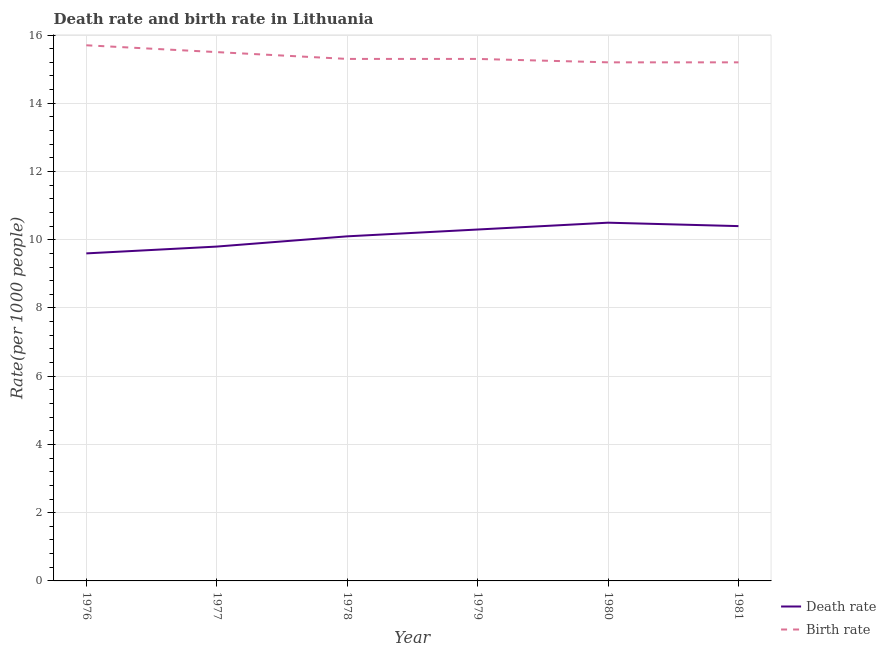How many different coloured lines are there?
Ensure brevity in your answer.  2. What is the birth rate in 1977?
Your response must be concise. 15.5. Across all years, what is the minimum death rate?
Provide a short and direct response. 9.6. In which year was the birth rate minimum?
Offer a very short reply. 1980. What is the total death rate in the graph?
Give a very brief answer. 60.7. What is the average death rate per year?
Ensure brevity in your answer.  10.12. In the year 1978, what is the difference between the death rate and birth rate?
Your response must be concise. -5.2. In how many years, is the birth rate greater than 11.6?
Provide a succinct answer. 6. What is the ratio of the birth rate in 1978 to that in 1981?
Your response must be concise. 1.01. Is the death rate in 1976 less than that in 1980?
Make the answer very short. Yes. Is the difference between the birth rate in 1976 and 1980 greater than the difference between the death rate in 1976 and 1980?
Offer a terse response. Yes. What is the difference between the highest and the second highest death rate?
Your response must be concise. 0.1. Does the death rate monotonically increase over the years?
Your answer should be very brief. No. Is the death rate strictly greater than the birth rate over the years?
Keep it short and to the point. No. Is the birth rate strictly less than the death rate over the years?
Provide a short and direct response. No. How many lines are there?
Offer a terse response. 2. What is the difference between two consecutive major ticks on the Y-axis?
Your answer should be very brief. 2. Are the values on the major ticks of Y-axis written in scientific E-notation?
Offer a very short reply. No. What is the title of the graph?
Your response must be concise. Death rate and birth rate in Lithuania. Does "Number of departures" appear as one of the legend labels in the graph?
Provide a succinct answer. No. What is the label or title of the X-axis?
Provide a short and direct response. Year. What is the label or title of the Y-axis?
Your answer should be very brief. Rate(per 1000 people). What is the Rate(per 1000 people) in Birth rate in 1976?
Your response must be concise. 15.7. What is the Rate(per 1000 people) in Birth rate in 1977?
Provide a succinct answer. 15.5. What is the Rate(per 1000 people) of Birth rate in 1978?
Make the answer very short. 15.3. What is the Rate(per 1000 people) of Birth rate in 1980?
Your response must be concise. 15.2. What is the Rate(per 1000 people) in Death rate in 1981?
Your response must be concise. 10.4. What is the Rate(per 1000 people) in Birth rate in 1981?
Your response must be concise. 15.2. Across all years, what is the maximum Rate(per 1000 people) of Death rate?
Give a very brief answer. 10.5. Across all years, what is the maximum Rate(per 1000 people) of Birth rate?
Your answer should be very brief. 15.7. What is the total Rate(per 1000 people) in Death rate in the graph?
Ensure brevity in your answer.  60.7. What is the total Rate(per 1000 people) of Birth rate in the graph?
Provide a succinct answer. 92.2. What is the difference between the Rate(per 1000 people) in Death rate in 1976 and that in 1977?
Provide a short and direct response. -0.2. What is the difference between the Rate(per 1000 people) of Birth rate in 1976 and that in 1977?
Provide a succinct answer. 0.2. What is the difference between the Rate(per 1000 people) of Death rate in 1976 and that in 1979?
Provide a succinct answer. -0.7. What is the difference between the Rate(per 1000 people) of Birth rate in 1976 and that in 1981?
Your answer should be very brief. 0.5. What is the difference between the Rate(per 1000 people) in Birth rate in 1977 and that in 1978?
Ensure brevity in your answer.  0.2. What is the difference between the Rate(per 1000 people) in Birth rate in 1977 and that in 1979?
Ensure brevity in your answer.  0.2. What is the difference between the Rate(per 1000 people) in Birth rate in 1977 and that in 1980?
Make the answer very short. 0.3. What is the difference between the Rate(per 1000 people) of Death rate in 1978 and that in 1979?
Give a very brief answer. -0.2. What is the difference between the Rate(per 1000 people) of Death rate in 1978 and that in 1980?
Your response must be concise. -0.4. What is the difference between the Rate(per 1000 people) of Birth rate in 1978 and that in 1980?
Your response must be concise. 0.1. What is the difference between the Rate(per 1000 people) of Death rate in 1978 and that in 1981?
Offer a terse response. -0.3. What is the difference between the Rate(per 1000 people) in Birth rate in 1979 and that in 1980?
Offer a very short reply. 0.1. What is the difference between the Rate(per 1000 people) in Death rate in 1979 and that in 1981?
Ensure brevity in your answer.  -0.1. What is the difference between the Rate(per 1000 people) in Death rate in 1977 and the Rate(per 1000 people) in Birth rate in 1978?
Your response must be concise. -5.5. What is the difference between the Rate(per 1000 people) in Death rate in 1977 and the Rate(per 1000 people) in Birth rate in 1980?
Keep it short and to the point. -5.4. What is the difference between the Rate(per 1000 people) in Death rate in 1977 and the Rate(per 1000 people) in Birth rate in 1981?
Provide a succinct answer. -5.4. What is the difference between the Rate(per 1000 people) of Death rate in 1978 and the Rate(per 1000 people) of Birth rate in 1979?
Offer a very short reply. -5.2. What is the difference between the Rate(per 1000 people) of Death rate in 1978 and the Rate(per 1000 people) of Birth rate in 1981?
Ensure brevity in your answer.  -5.1. What is the difference between the Rate(per 1000 people) of Death rate in 1979 and the Rate(per 1000 people) of Birth rate in 1980?
Your response must be concise. -4.9. What is the difference between the Rate(per 1000 people) in Death rate in 1980 and the Rate(per 1000 people) in Birth rate in 1981?
Your answer should be very brief. -4.7. What is the average Rate(per 1000 people) in Death rate per year?
Make the answer very short. 10.12. What is the average Rate(per 1000 people) in Birth rate per year?
Provide a short and direct response. 15.37. In the year 1978, what is the difference between the Rate(per 1000 people) of Death rate and Rate(per 1000 people) of Birth rate?
Your answer should be compact. -5.2. In the year 1980, what is the difference between the Rate(per 1000 people) of Death rate and Rate(per 1000 people) of Birth rate?
Provide a succinct answer. -4.7. In the year 1981, what is the difference between the Rate(per 1000 people) in Death rate and Rate(per 1000 people) in Birth rate?
Offer a terse response. -4.8. What is the ratio of the Rate(per 1000 people) in Death rate in 1976 to that in 1977?
Ensure brevity in your answer.  0.98. What is the ratio of the Rate(per 1000 people) of Birth rate in 1976 to that in 1977?
Make the answer very short. 1.01. What is the ratio of the Rate(per 1000 people) in Death rate in 1976 to that in 1978?
Keep it short and to the point. 0.95. What is the ratio of the Rate(per 1000 people) in Birth rate in 1976 to that in 1978?
Make the answer very short. 1.03. What is the ratio of the Rate(per 1000 people) of Death rate in 1976 to that in 1979?
Provide a succinct answer. 0.93. What is the ratio of the Rate(per 1000 people) in Birth rate in 1976 to that in 1979?
Make the answer very short. 1.03. What is the ratio of the Rate(per 1000 people) of Death rate in 1976 to that in 1980?
Provide a succinct answer. 0.91. What is the ratio of the Rate(per 1000 people) of Birth rate in 1976 to that in 1980?
Give a very brief answer. 1.03. What is the ratio of the Rate(per 1000 people) in Death rate in 1976 to that in 1981?
Your response must be concise. 0.92. What is the ratio of the Rate(per 1000 people) in Birth rate in 1976 to that in 1981?
Give a very brief answer. 1.03. What is the ratio of the Rate(per 1000 people) in Death rate in 1977 to that in 1978?
Your answer should be very brief. 0.97. What is the ratio of the Rate(per 1000 people) in Birth rate in 1977 to that in 1978?
Your answer should be compact. 1.01. What is the ratio of the Rate(per 1000 people) of Death rate in 1977 to that in 1979?
Provide a short and direct response. 0.95. What is the ratio of the Rate(per 1000 people) in Birth rate in 1977 to that in 1979?
Provide a succinct answer. 1.01. What is the ratio of the Rate(per 1000 people) in Death rate in 1977 to that in 1980?
Offer a terse response. 0.93. What is the ratio of the Rate(per 1000 people) of Birth rate in 1977 to that in 1980?
Offer a very short reply. 1.02. What is the ratio of the Rate(per 1000 people) in Death rate in 1977 to that in 1981?
Provide a succinct answer. 0.94. What is the ratio of the Rate(per 1000 people) of Birth rate in 1977 to that in 1981?
Provide a succinct answer. 1.02. What is the ratio of the Rate(per 1000 people) of Death rate in 1978 to that in 1979?
Your answer should be very brief. 0.98. What is the ratio of the Rate(per 1000 people) of Death rate in 1978 to that in 1980?
Offer a terse response. 0.96. What is the ratio of the Rate(per 1000 people) of Birth rate in 1978 to that in 1980?
Make the answer very short. 1.01. What is the ratio of the Rate(per 1000 people) in Death rate in 1978 to that in 1981?
Keep it short and to the point. 0.97. What is the ratio of the Rate(per 1000 people) of Birth rate in 1978 to that in 1981?
Offer a terse response. 1.01. What is the ratio of the Rate(per 1000 people) of Birth rate in 1979 to that in 1980?
Provide a short and direct response. 1.01. What is the ratio of the Rate(per 1000 people) of Death rate in 1979 to that in 1981?
Your answer should be compact. 0.99. What is the ratio of the Rate(per 1000 people) in Birth rate in 1979 to that in 1981?
Ensure brevity in your answer.  1.01. What is the ratio of the Rate(per 1000 people) in Death rate in 1980 to that in 1981?
Provide a short and direct response. 1.01. What is the ratio of the Rate(per 1000 people) of Birth rate in 1980 to that in 1981?
Your answer should be very brief. 1. What is the difference between the highest and the lowest Rate(per 1000 people) of Death rate?
Offer a very short reply. 0.9. 